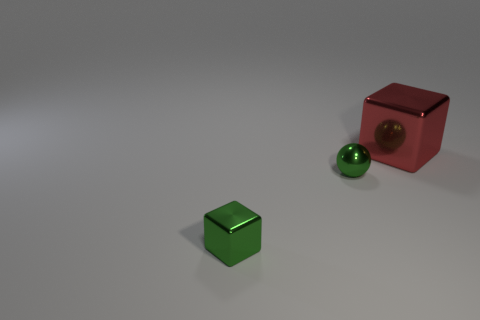Subtract all cyan blocks. Subtract all gray balls. How many blocks are left? 2 Add 3 shiny balls. How many objects exist? 6 Subtract all cubes. How many objects are left? 1 Add 3 cyan blocks. How many cyan blocks exist? 3 Subtract 0 brown balls. How many objects are left? 3 Subtract all green spheres. Subtract all green cubes. How many objects are left? 1 Add 2 big blocks. How many big blocks are left? 3 